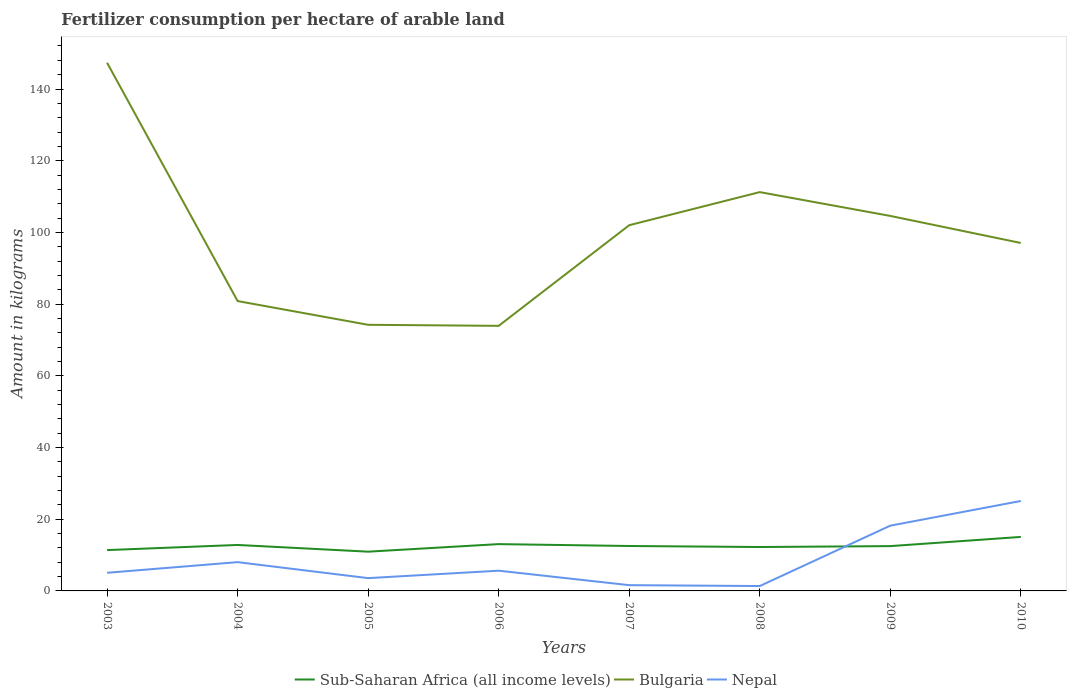How many different coloured lines are there?
Your answer should be compact. 3. Is the number of lines equal to the number of legend labels?
Provide a succinct answer. Yes. Across all years, what is the maximum amount of fertilizer consumption in Sub-Saharan Africa (all income levels)?
Your response must be concise. 10.95. What is the total amount of fertilizer consumption in Nepal in the graph?
Offer a very short reply. 4.03. What is the difference between the highest and the second highest amount of fertilizer consumption in Bulgaria?
Make the answer very short. 73.39. How many lines are there?
Make the answer very short. 3. How many years are there in the graph?
Offer a terse response. 8. Are the values on the major ticks of Y-axis written in scientific E-notation?
Offer a terse response. No. Does the graph contain any zero values?
Your answer should be compact. No. Does the graph contain grids?
Your answer should be compact. No. Where does the legend appear in the graph?
Ensure brevity in your answer.  Bottom center. What is the title of the graph?
Provide a succinct answer. Fertilizer consumption per hectare of arable land. What is the label or title of the X-axis?
Your answer should be very brief. Years. What is the label or title of the Y-axis?
Keep it short and to the point. Amount in kilograms. What is the Amount in kilograms in Sub-Saharan Africa (all income levels) in 2003?
Provide a succinct answer. 11.39. What is the Amount in kilograms in Bulgaria in 2003?
Ensure brevity in your answer.  147.33. What is the Amount in kilograms of Nepal in 2003?
Give a very brief answer. 5.06. What is the Amount in kilograms in Sub-Saharan Africa (all income levels) in 2004?
Your answer should be compact. 12.82. What is the Amount in kilograms of Bulgaria in 2004?
Ensure brevity in your answer.  80.85. What is the Amount in kilograms of Nepal in 2004?
Provide a short and direct response. 8.03. What is the Amount in kilograms of Sub-Saharan Africa (all income levels) in 2005?
Your response must be concise. 10.95. What is the Amount in kilograms of Bulgaria in 2005?
Give a very brief answer. 74.23. What is the Amount in kilograms in Nepal in 2005?
Your answer should be compact. 3.57. What is the Amount in kilograms of Sub-Saharan Africa (all income levels) in 2006?
Give a very brief answer. 13.06. What is the Amount in kilograms of Bulgaria in 2006?
Ensure brevity in your answer.  73.94. What is the Amount in kilograms in Nepal in 2006?
Offer a very short reply. 5.64. What is the Amount in kilograms of Sub-Saharan Africa (all income levels) in 2007?
Ensure brevity in your answer.  12.53. What is the Amount in kilograms of Bulgaria in 2007?
Make the answer very short. 102.01. What is the Amount in kilograms of Nepal in 2007?
Keep it short and to the point. 1.61. What is the Amount in kilograms of Sub-Saharan Africa (all income levels) in 2008?
Give a very brief answer. 12.25. What is the Amount in kilograms of Bulgaria in 2008?
Offer a terse response. 111.24. What is the Amount in kilograms in Nepal in 2008?
Provide a succinct answer. 1.36. What is the Amount in kilograms in Sub-Saharan Africa (all income levels) in 2009?
Keep it short and to the point. 12.5. What is the Amount in kilograms of Bulgaria in 2009?
Your answer should be very brief. 104.6. What is the Amount in kilograms of Nepal in 2009?
Make the answer very short. 18.2. What is the Amount in kilograms in Sub-Saharan Africa (all income levels) in 2010?
Your answer should be very brief. 15.06. What is the Amount in kilograms in Bulgaria in 2010?
Your answer should be very brief. 97.05. What is the Amount in kilograms in Nepal in 2010?
Your answer should be very brief. 25.09. Across all years, what is the maximum Amount in kilograms in Sub-Saharan Africa (all income levels)?
Your answer should be compact. 15.06. Across all years, what is the maximum Amount in kilograms of Bulgaria?
Your answer should be very brief. 147.33. Across all years, what is the maximum Amount in kilograms in Nepal?
Offer a terse response. 25.09. Across all years, what is the minimum Amount in kilograms in Sub-Saharan Africa (all income levels)?
Provide a succinct answer. 10.95. Across all years, what is the minimum Amount in kilograms in Bulgaria?
Give a very brief answer. 73.94. Across all years, what is the minimum Amount in kilograms in Nepal?
Make the answer very short. 1.36. What is the total Amount in kilograms in Sub-Saharan Africa (all income levels) in the graph?
Offer a terse response. 100.55. What is the total Amount in kilograms in Bulgaria in the graph?
Provide a short and direct response. 791.26. What is the total Amount in kilograms in Nepal in the graph?
Give a very brief answer. 68.56. What is the difference between the Amount in kilograms in Sub-Saharan Africa (all income levels) in 2003 and that in 2004?
Offer a terse response. -1.43. What is the difference between the Amount in kilograms in Bulgaria in 2003 and that in 2004?
Your response must be concise. 66.48. What is the difference between the Amount in kilograms of Nepal in 2003 and that in 2004?
Provide a short and direct response. -2.97. What is the difference between the Amount in kilograms of Sub-Saharan Africa (all income levels) in 2003 and that in 2005?
Your response must be concise. 0.44. What is the difference between the Amount in kilograms of Bulgaria in 2003 and that in 2005?
Give a very brief answer. 73.1. What is the difference between the Amount in kilograms in Nepal in 2003 and that in 2005?
Offer a very short reply. 1.49. What is the difference between the Amount in kilograms in Sub-Saharan Africa (all income levels) in 2003 and that in 2006?
Offer a terse response. -1.67. What is the difference between the Amount in kilograms of Bulgaria in 2003 and that in 2006?
Provide a succinct answer. 73.39. What is the difference between the Amount in kilograms in Nepal in 2003 and that in 2006?
Keep it short and to the point. -0.58. What is the difference between the Amount in kilograms of Sub-Saharan Africa (all income levels) in 2003 and that in 2007?
Keep it short and to the point. -1.14. What is the difference between the Amount in kilograms in Bulgaria in 2003 and that in 2007?
Provide a succinct answer. 45.32. What is the difference between the Amount in kilograms of Nepal in 2003 and that in 2007?
Make the answer very short. 3.45. What is the difference between the Amount in kilograms of Sub-Saharan Africa (all income levels) in 2003 and that in 2008?
Your answer should be very brief. -0.86. What is the difference between the Amount in kilograms in Bulgaria in 2003 and that in 2008?
Provide a short and direct response. 36.08. What is the difference between the Amount in kilograms in Nepal in 2003 and that in 2008?
Give a very brief answer. 3.69. What is the difference between the Amount in kilograms in Sub-Saharan Africa (all income levels) in 2003 and that in 2009?
Give a very brief answer. -1.11. What is the difference between the Amount in kilograms of Bulgaria in 2003 and that in 2009?
Make the answer very short. 42.73. What is the difference between the Amount in kilograms in Nepal in 2003 and that in 2009?
Offer a very short reply. -13.14. What is the difference between the Amount in kilograms of Sub-Saharan Africa (all income levels) in 2003 and that in 2010?
Offer a very short reply. -3.67. What is the difference between the Amount in kilograms in Bulgaria in 2003 and that in 2010?
Keep it short and to the point. 50.27. What is the difference between the Amount in kilograms of Nepal in 2003 and that in 2010?
Keep it short and to the point. -20.03. What is the difference between the Amount in kilograms of Sub-Saharan Africa (all income levels) in 2004 and that in 2005?
Provide a succinct answer. 1.87. What is the difference between the Amount in kilograms of Bulgaria in 2004 and that in 2005?
Your answer should be compact. 6.62. What is the difference between the Amount in kilograms of Nepal in 2004 and that in 2005?
Make the answer very short. 4.46. What is the difference between the Amount in kilograms in Sub-Saharan Africa (all income levels) in 2004 and that in 2006?
Offer a terse response. -0.24. What is the difference between the Amount in kilograms of Bulgaria in 2004 and that in 2006?
Provide a succinct answer. 6.91. What is the difference between the Amount in kilograms of Nepal in 2004 and that in 2006?
Offer a very short reply. 2.38. What is the difference between the Amount in kilograms of Sub-Saharan Africa (all income levels) in 2004 and that in 2007?
Give a very brief answer. 0.29. What is the difference between the Amount in kilograms of Bulgaria in 2004 and that in 2007?
Provide a succinct answer. -21.16. What is the difference between the Amount in kilograms in Nepal in 2004 and that in 2007?
Give a very brief answer. 6.42. What is the difference between the Amount in kilograms in Sub-Saharan Africa (all income levels) in 2004 and that in 2008?
Offer a very short reply. 0.57. What is the difference between the Amount in kilograms of Bulgaria in 2004 and that in 2008?
Offer a very short reply. -30.39. What is the difference between the Amount in kilograms of Nepal in 2004 and that in 2008?
Keep it short and to the point. 6.66. What is the difference between the Amount in kilograms of Sub-Saharan Africa (all income levels) in 2004 and that in 2009?
Your response must be concise. 0.32. What is the difference between the Amount in kilograms of Bulgaria in 2004 and that in 2009?
Your response must be concise. -23.75. What is the difference between the Amount in kilograms in Nepal in 2004 and that in 2009?
Make the answer very short. -10.18. What is the difference between the Amount in kilograms of Sub-Saharan Africa (all income levels) in 2004 and that in 2010?
Ensure brevity in your answer.  -2.24. What is the difference between the Amount in kilograms of Bulgaria in 2004 and that in 2010?
Ensure brevity in your answer.  -16.2. What is the difference between the Amount in kilograms of Nepal in 2004 and that in 2010?
Your answer should be very brief. -17.06. What is the difference between the Amount in kilograms in Sub-Saharan Africa (all income levels) in 2005 and that in 2006?
Offer a very short reply. -2.11. What is the difference between the Amount in kilograms in Bulgaria in 2005 and that in 2006?
Ensure brevity in your answer.  0.29. What is the difference between the Amount in kilograms of Nepal in 2005 and that in 2006?
Offer a very short reply. -2.07. What is the difference between the Amount in kilograms of Sub-Saharan Africa (all income levels) in 2005 and that in 2007?
Give a very brief answer. -1.58. What is the difference between the Amount in kilograms in Bulgaria in 2005 and that in 2007?
Your response must be concise. -27.78. What is the difference between the Amount in kilograms in Nepal in 2005 and that in 2007?
Offer a very short reply. 1.96. What is the difference between the Amount in kilograms of Sub-Saharan Africa (all income levels) in 2005 and that in 2008?
Your answer should be compact. -1.3. What is the difference between the Amount in kilograms of Bulgaria in 2005 and that in 2008?
Offer a terse response. -37.01. What is the difference between the Amount in kilograms in Nepal in 2005 and that in 2008?
Provide a succinct answer. 2.2. What is the difference between the Amount in kilograms of Sub-Saharan Africa (all income levels) in 2005 and that in 2009?
Provide a short and direct response. -1.55. What is the difference between the Amount in kilograms of Bulgaria in 2005 and that in 2009?
Your response must be concise. -30.37. What is the difference between the Amount in kilograms in Nepal in 2005 and that in 2009?
Your answer should be very brief. -14.63. What is the difference between the Amount in kilograms in Sub-Saharan Africa (all income levels) in 2005 and that in 2010?
Make the answer very short. -4.11. What is the difference between the Amount in kilograms in Bulgaria in 2005 and that in 2010?
Keep it short and to the point. -22.82. What is the difference between the Amount in kilograms in Nepal in 2005 and that in 2010?
Ensure brevity in your answer.  -21.52. What is the difference between the Amount in kilograms of Sub-Saharan Africa (all income levels) in 2006 and that in 2007?
Make the answer very short. 0.53. What is the difference between the Amount in kilograms of Bulgaria in 2006 and that in 2007?
Your answer should be compact. -28.07. What is the difference between the Amount in kilograms in Nepal in 2006 and that in 2007?
Provide a succinct answer. 4.03. What is the difference between the Amount in kilograms of Sub-Saharan Africa (all income levels) in 2006 and that in 2008?
Your response must be concise. 0.81. What is the difference between the Amount in kilograms in Bulgaria in 2006 and that in 2008?
Offer a terse response. -37.3. What is the difference between the Amount in kilograms of Nepal in 2006 and that in 2008?
Give a very brief answer. 4.28. What is the difference between the Amount in kilograms of Sub-Saharan Africa (all income levels) in 2006 and that in 2009?
Ensure brevity in your answer.  0.56. What is the difference between the Amount in kilograms in Bulgaria in 2006 and that in 2009?
Ensure brevity in your answer.  -30.66. What is the difference between the Amount in kilograms of Nepal in 2006 and that in 2009?
Give a very brief answer. -12.56. What is the difference between the Amount in kilograms in Sub-Saharan Africa (all income levels) in 2006 and that in 2010?
Give a very brief answer. -2. What is the difference between the Amount in kilograms in Bulgaria in 2006 and that in 2010?
Give a very brief answer. -23.11. What is the difference between the Amount in kilograms of Nepal in 2006 and that in 2010?
Give a very brief answer. -19.44. What is the difference between the Amount in kilograms in Sub-Saharan Africa (all income levels) in 2007 and that in 2008?
Offer a terse response. 0.28. What is the difference between the Amount in kilograms in Bulgaria in 2007 and that in 2008?
Provide a succinct answer. -9.23. What is the difference between the Amount in kilograms in Nepal in 2007 and that in 2008?
Give a very brief answer. 0.24. What is the difference between the Amount in kilograms of Sub-Saharan Africa (all income levels) in 2007 and that in 2009?
Ensure brevity in your answer.  0.03. What is the difference between the Amount in kilograms in Bulgaria in 2007 and that in 2009?
Your answer should be compact. -2.59. What is the difference between the Amount in kilograms in Nepal in 2007 and that in 2009?
Ensure brevity in your answer.  -16.59. What is the difference between the Amount in kilograms in Sub-Saharan Africa (all income levels) in 2007 and that in 2010?
Make the answer very short. -2.53. What is the difference between the Amount in kilograms in Bulgaria in 2007 and that in 2010?
Your answer should be compact. 4.96. What is the difference between the Amount in kilograms of Nepal in 2007 and that in 2010?
Provide a short and direct response. -23.48. What is the difference between the Amount in kilograms in Sub-Saharan Africa (all income levels) in 2008 and that in 2009?
Your response must be concise. -0.25. What is the difference between the Amount in kilograms in Bulgaria in 2008 and that in 2009?
Your answer should be very brief. 6.64. What is the difference between the Amount in kilograms in Nepal in 2008 and that in 2009?
Your answer should be very brief. -16.84. What is the difference between the Amount in kilograms in Sub-Saharan Africa (all income levels) in 2008 and that in 2010?
Give a very brief answer. -2.81. What is the difference between the Amount in kilograms of Bulgaria in 2008 and that in 2010?
Your answer should be very brief. 14.19. What is the difference between the Amount in kilograms in Nepal in 2008 and that in 2010?
Offer a very short reply. -23.72. What is the difference between the Amount in kilograms in Sub-Saharan Africa (all income levels) in 2009 and that in 2010?
Offer a terse response. -2.56. What is the difference between the Amount in kilograms of Bulgaria in 2009 and that in 2010?
Offer a terse response. 7.55. What is the difference between the Amount in kilograms in Nepal in 2009 and that in 2010?
Your answer should be very brief. -6.88. What is the difference between the Amount in kilograms in Sub-Saharan Africa (all income levels) in 2003 and the Amount in kilograms in Bulgaria in 2004?
Provide a succinct answer. -69.46. What is the difference between the Amount in kilograms of Sub-Saharan Africa (all income levels) in 2003 and the Amount in kilograms of Nepal in 2004?
Make the answer very short. 3.37. What is the difference between the Amount in kilograms of Bulgaria in 2003 and the Amount in kilograms of Nepal in 2004?
Your answer should be very brief. 139.3. What is the difference between the Amount in kilograms in Sub-Saharan Africa (all income levels) in 2003 and the Amount in kilograms in Bulgaria in 2005?
Make the answer very short. -62.84. What is the difference between the Amount in kilograms of Sub-Saharan Africa (all income levels) in 2003 and the Amount in kilograms of Nepal in 2005?
Offer a very short reply. 7.82. What is the difference between the Amount in kilograms of Bulgaria in 2003 and the Amount in kilograms of Nepal in 2005?
Give a very brief answer. 143.76. What is the difference between the Amount in kilograms of Sub-Saharan Africa (all income levels) in 2003 and the Amount in kilograms of Bulgaria in 2006?
Make the answer very short. -62.55. What is the difference between the Amount in kilograms in Sub-Saharan Africa (all income levels) in 2003 and the Amount in kilograms in Nepal in 2006?
Your answer should be very brief. 5.75. What is the difference between the Amount in kilograms in Bulgaria in 2003 and the Amount in kilograms in Nepal in 2006?
Provide a succinct answer. 141.69. What is the difference between the Amount in kilograms of Sub-Saharan Africa (all income levels) in 2003 and the Amount in kilograms of Bulgaria in 2007?
Provide a succinct answer. -90.62. What is the difference between the Amount in kilograms of Sub-Saharan Africa (all income levels) in 2003 and the Amount in kilograms of Nepal in 2007?
Offer a very short reply. 9.78. What is the difference between the Amount in kilograms of Bulgaria in 2003 and the Amount in kilograms of Nepal in 2007?
Keep it short and to the point. 145.72. What is the difference between the Amount in kilograms of Sub-Saharan Africa (all income levels) in 2003 and the Amount in kilograms of Bulgaria in 2008?
Offer a terse response. -99.85. What is the difference between the Amount in kilograms of Sub-Saharan Africa (all income levels) in 2003 and the Amount in kilograms of Nepal in 2008?
Your response must be concise. 10.03. What is the difference between the Amount in kilograms of Bulgaria in 2003 and the Amount in kilograms of Nepal in 2008?
Keep it short and to the point. 145.96. What is the difference between the Amount in kilograms in Sub-Saharan Africa (all income levels) in 2003 and the Amount in kilograms in Bulgaria in 2009?
Make the answer very short. -93.21. What is the difference between the Amount in kilograms of Sub-Saharan Africa (all income levels) in 2003 and the Amount in kilograms of Nepal in 2009?
Provide a succinct answer. -6.81. What is the difference between the Amount in kilograms in Bulgaria in 2003 and the Amount in kilograms in Nepal in 2009?
Offer a terse response. 129.12. What is the difference between the Amount in kilograms of Sub-Saharan Africa (all income levels) in 2003 and the Amount in kilograms of Bulgaria in 2010?
Provide a short and direct response. -85.66. What is the difference between the Amount in kilograms in Sub-Saharan Africa (all income levels) in 2003 and the Amount in kilograms in Nepal in 2010?
Keep it short and to the point. -13.7. What is the difference between the Amount in kilograms of Bulgaria in 2003 and the Amount in kilograms of Nepal in 2010?
Give a very brief answer. 122.24. What is the difference between the Amount in kilograms of Sub-Saharan Africa (all income levels) in 2004 and the Amount in kilograms of Bulgaria in 2005?
Offer a terse response. -61.41. What is the difference between the Amount in kilograms of Sub-Saharan Africa (all income levels) in 2004 and the Amount in kilograms of Nepal in 2005?
Provide a short and direct response. 9.25. What is the difference between the Amount in kilograms of Bulgaria in 2004 and the Amount in kilograms of Nepal in 2005?
Provide a succinct answer. 77.28. What is the difference between the Amount in kilograms in Sub-Saharan Africa (all income levels) in 2004 and the Amount in kilograms in Bulgaria in 2006?
Offer a terse response. -61.12. What is the difference between the Amount in kilograms of Sub-Saharan Africa (all income levels) in 2004 and the Amount in kilograms of Nepal in 2006?
Keep it short and to the point. 7.18. What is the difference between the Amount in kilograms in Bulgaria in 2004 and the Amount in kilograms in Nepal in 2006?
Offer a very short reply. 75.21. What is the difference between the Amount in kilograms in Sub-Saharan Africa (all income levels) in 2004 and the Amount in kilograms in Bulgaria in 2007?
Provide a succinct answer. -89.19. What is the difference between the Amount in kilograms of Sub-Saharan Africa (all income levels) in 2004 and the Amount in kilograms of Nepal in 2007?
Provide a succinct answer. 11.21. What is the difference between the Amount in kilograms in Bulgaria in 2004 and the Amount in kilograms in Nepal in 2007?
Keep it short and to the point. 79.24. What is the difference between the Amount in kilograms of Sub-Saharan Africa (all income levels) in 2004 and the Amount in kilograms of Bulgaria in 2008?
Keep it short and to the point. -98.42. What is the difference between the Amount in kilograms in Sub-Saharan Africa (all income levels) in 2004 and the Amount in kilograms in Nepal in 2008?
Offer a terse response. 11.46. What is the difference between the Amount in kilograms in Bulgaria in 2004 and the Amount in kilograms in Nepal in 2008?
Keep it short and to the point. 79.49. What is the difference between the Amount in kilograms in Sub-Saharan Africa (all income levels) in 2004 and the Amount in kilograms in Bulgaria in 2009?
Your answer should be compact. -91.78. What is the difference between the Amount in kilograms in Sub-Saharan Africa (all income levels) in 2004 and the Amount in kilograms in Nepal in 2009?
Keep it short and to the point. -5.38. What is the difference between the Amount in kilograms of Bulgaria in 2004 and the Amount in kilograms of Nepal in 2009?
Make the answer very short. 62.65. What is the difference between the Amount in kilograms of Sub-Saharan Africa (all income levels) in 2004 and the Amount in kilograms of Bulgaria in 2010?
Provide a short and direct response. -84.23. What is the difference between the Amount in kilograms in Sub-Saharan Africa (all income levels) in 2004 and the Amount in kilograms in Nepal in 2010?
Your response must be concise. -12.27. What is the difference between the Amount in kilograms of Bulgaria in 2004 and the Amount in kilograms of Nepal in 2010?
Ensure brevity in your answer.  55.77. What is the difference between the Amount in kilograms in Sub-Saharan Africa (all income levels) in 2005 and the Amount in kilograms in Bulgaria in 2006?
Your answer should be compact. -62.99. What is the difference between the Amount in kilograms in Sub-Saharan Africa (all income levels) in 2005 and the Amount in kilograms in Nepal in 2006?
Offer a very short reply. 5.31. What is the difference between the Amount in kilograms of Bulgaria in 2005 and the Amount in kilograms of Nepal in 2006?
Provide a succinct answer. 68.59. What is the difference between the Amount in kilograms of Sub-Saharan Africa (all income levels) in 2005 and the Amount in kilograms of Bulgaria in 2007?
Keep it short and to the point. -91.06. What is the difference between the Amount in kilograms in Sub-Saharan Africa (all income levels) in 2005 and the Amount in kilograms in Nepal in 2007?
Offer a very short reply. 9.34. What is the difference between the Amount in kilograms of Bulgaria in 2005 and the Amount in kilograms of Nepal in 2007?
Ensure brevity in your answer.  72.62. What is the difference between the Amount in kilograms of Sub-Saharan Africa (all income levels) in 2005 and the Amount in kilograms of Bulgaria in 2008?
Give a very brief answer. -100.29. What is the difference between the Amount in kilograms of Sub-Saharan Africa (all income levels) in 2005 and the Amount in kilograms of Nepal in 2008?
Give a very brief answer. 9.58. What is the difference between the Amount in kilograms in Bulgaria in 2005 and the Amount in kilograms in Nepal in 2008?
Provide a short and direct response. 72.87. What is the difference between the Amount in kilograms of Sub-Saharan Africa (all income levels) in 2005 and the Amount in kilograms of Bulgaria in 2009?
Make the answer very short. -93.65. What is the difference between the Amount in kilograms in Sub-Saharan Africa (all income levels) in 2005 and the Amount in kilograms in Nepal in 2009?
Make the answer very short. -7.25. What is the difference between the Amount in kilograms of Bulgaria in 2005 and the Amount in kilograms of Nepal in 2009?
Provide a short and direct response. 56.03. What is the difference between the Amount in kilograms of Sub-Saharan Africa (all income levels) in 2005 and the Amount in kilograms of Bulgaria in 2010?
Give a very brief answer. -86.1. What is the difference between the Amount in kilograms in Sub-Saharan Africa (all income levels) in 2005 and the Amount in kilograms in Nepal in 2010?
Keep it short and to the point. -14.14. What is the difference between the Amount in kilograms in Bulgaria in 2005 and the Amount in kilograms in Nepal in 2010?
Give a very brief answer. 49.15. What is the difference between the Amount in kilograms of Sub-Saharan Africa (all income levels) in 2006 and the Amount in kilograms of Bulgaria in 2007?
Offer a terse response. -88.95. What is the difference between the Amount in kilograms of Sub-Saharan Africa (all income levels) in 2006 and the Amount in kilograms of Nepal in 2007?
Your answer should be compact. 11.45. What is the difference between the Amount in kilograms of Bulgaria in 2006 and the Amount in kilograms of Nepal in 2007?
Offer a very short reply. 72.33. What is the difference between the Amount in kilograms of Sub-Saharan Africa (all income levels) in 2006 and the Amount in kilograms of Bulgaria in 2008?
Offer a very short reply. -98.19. What is the difference between the Amount in kilograms of Sub-Saharan Africa (all income levels) in 2006 and the Amount in kilograms of Nepal in 2008?
Make the answer very short. 11.69. What is the difference between the Amount in kilograms in Bulgaria in 2006 and the Amount in kilograms in Nepal in 2008?
Ensure brevity in your answer.  72.58. What is the difference between the Amount in kilograms of Sub-Saharan Africa (all income levels) in 2006 and the Amount in kilograms of Bulgaria in 2009?
Your response must be concise. -91.54. What is the difference between the Amount in kilograms in Sub-Saharan Africa (all income levels) in 2006 and the Amount in kilograms in Nepal in 2009?
Make the answer very short. -5.15. What is the difference between the Amount in kilograms in Bulgaria in 2006 and the Amount in kilograms in Nepal in 2009?
Your answer should be very brief. 55.74. What is the difference between the Amount in kilograms of Sub-Saharan Africa (all income levels) in 2006 and the Amount in kilograms of Bulgaria in 2010?
Give a very brief answer. -84. What is the difference between the Amount in kilograms in Sub-Saharan Africa (all income levels) in 2006 and the Amount in kilograms in Nepal in 2010?
Give a very brief answer. -12.03. What is the difference between the Amount in kilograms of Bulgaria in 2006 and the Amount in kilograms of Nepal in 2010?
Your answer should be compact. 48.85. What is the difference between the Amount in kilograms in Sub-Saharan Africa (all income levels) in 2007 and the Amount in kilograms in Bulgaria in 2008?
Ensure brevity in your answer.  -98.71. What is the difference between the Amount in kilograms of Sub-Saharan Africa (all income levels) in 2007 and the Amount in kilograms of Nepal in 2008?
Provide a short and direct response. 11.16. What is the difference between the Amount in kilograms of Bulgaria in 2007 and the Amount in kilograms of Nepal in 2008?
Ensure brevity in your answer.  100.64. What is the difference between the Amount in kilograms in Sub-Saharan Africa (all income levels) in 2007 and the Amount in kilograms in Bulgaria in 2009?
Your response must be concise. -92.07. What is the difference between the Amount in kilograms in Sub-Saharan Africa (all income levels) in 2007 and the Amount in kilograms in Nepal in 2009?
Keep it short and to the point. -5.67. What is the difference between the Amount in kilograms of Bulgaria in 2007 and the Amount in kilograms of Nepal in 2009?
Ensure brevity in your answer.  83.81. What is the difference between the Amount in kilograms in Sub-Saharan Africa (all income levels) in 2007 and the Amount in kilograms in Bulgaria in 2010?
Keep it short and to the point. -84.53. What is the difference between the Amount in kilograms in Sub-Saharan Africa (all income levels) in 2007 and the Amount in kilograms in Nepal in 2010?
Keep it short and to the point. -12.56. What is the difference between the Amount in kilograms of Bulgaria in 2007 and the Amount in kilograms of Nepal in 2010?
Your answer should be compact. 76.92. What is the difference between the Amount in kilograms in Sub-Saharan Africa (all income levels) in 2008 and the Amount in kilograms in Bulgaria in 2009?
Provide a short and direct response. -92.35. What is the difference between the Amount in kilograms in Sub-Saharan Africa (all income levels) in 2008 and the Amount in kilograms in Nepal in 2009?
Provide a succinct answer. -5.96. What is the difference between the Amount in kilograms of Bulgaria in 2008 and the Amount in kilograms of Nepal in 2009?
Provide a succinct answer. 93.04. What is the difference between the Amount in kilograms of Sub-Saharan Africa (all income levels) in 2008 and the Amount in kilograms of Bulgaria in 2010?
Your answer should be very brief. -84.81. What is the difference between the Amount in kilograms of Sub-Saharan Africa (all income levels) in 2008 and the Amount in kilograms of Nepal in 2010?
Ensure brevity in your answer.  -12.84. What is the difference between the Amount in kilograms in Bulgaria in 2008 and the Amount in kilograms in Nepal in 2010?
Provide a short and direct response. 86.16. What is the difference between the Amount in kilograms in Sub-Saharan Africa (all income levels) in 2009 and the Amount in kilograms in Bulgaria in 2010?
Provide a short and direct response. -84.55. What is the difference between the Amount in kilograms in Sub-Saharan Africa (all income levels) in 2009 and the Amount in kilograms in Nepal in 2010?
Your response must be concise. -12.59. What is the difference between the Amount in kilograms of Bulgaria in 2009 and the Amount in kilograms of Nepal in 2010?
Your answer should be very brief. 79.51. What is the average Amount in kilograms of Sub-Saharan Africa (all income levels) per year?
Your response must be concise. 12.57. What is the average Amount in kilograms of Bulgaria per year?
Keep it short and to the point. 98.91. What is the average Amount in kilograms in Nepal per year?
Your answer should be compact. 8.57. In the year 2003, what is the difference between the Amount in kilograms of Sub-Saharan Africa (all income levels) and Amount in kilograms of Bulgaria?
Your answer should be very brief. -135.94. In the year 2003, what is the difference between the Amount in kilograms in Sub-Saharan Africa (all income levels) and Amount in kilograms in Nepal?
Give a very brief answer. 6.33. In the year 2003, what is the difference between the Amount in kilograms of Bulgaria and Amount in kilograms of Nepal?
Offer a terse response. 142.27. In the year 2004, what is the difference between the Amount in kilograms in Sub-Saharan Africa (all income levels) and Amount in kilograms in Bulgaria?
Provide a succinct answer. -68.03. In the year 2004, what is the difference between the Amount in kilograms of Sub-Saharan Africa (all income levels) and Amount in kilograms of Nepal?
Your response must be concise. 4.8. In the year 2004, what is the difference between the Amount in kilograms in Bulgaria and Amount in kilograms in Nepal?
Provide a succinct answer. 72.83. In the year 2005, what is the difference between the Amount in kilograms in Sub-Saharan Africa (all income levels) and Amount in kilograms in Bulgaria?
Your answer should be compact. -63.28. In the year 2005, what is the difference between the Amount in kilograms of Sub-Saharan Africa (all income levels) and Amount in kilograms of Nepal?
Provide a short and direct response. 7.38. In the year 2005, what is the difference between the Amount in kilograms of Bulgaria and Amount in kilograms of Nepal?
Give a very brief answer. 70.66. In the year 2006, what is the difference between the Amount in kilograms in Sub-Saharan Africa (all income levels) and Amount in kilograms in Bulgaria?
Offer a terse response. -60.88. In the year 2006, what is the difference between the Amount in kilograms in Sub-Saharan Africa (all income levels) and Amount in kilograms in Nepal?
Provide a short and direct response. 7.42. In the year 2006, what is the difference between the Amount in kilograms of Bulgaria and Amount in kilograms of Nepal?
Ensure brevity in your answer.  68.3. In the year 2007, what is the difference between the Amount in kilograms of Sub-Saharan Africa (all income levels) and Amount in kilograms of Bulgaria?
Keep it short and to the point. -89.48. In the year 2007, what is the difference between the Amount in kilograms of Sub-Saharan Africa (all income levels) and Amount in kilograms of Nepal?
Provide a succinct answer. 10.92. In the year 2007, what is the difference between the Amount in kilograms in Bulgaria and Amount in kilograms in Nepal?
Your answer should be very brief. 100.4. In the year 2008, what is the difference between the Amount in kilograms in Sub-Saharan Africa (all income levels) and Amount in kilograms in Bulgaria?
Keep it short and to the point. -99. In the year 2008, what is the difference between the Amount in kilograms of Sub-Saharan Africa (all income levels) and Amount in kilograms of Nepal?
Provide a succinct answer. 10.88. In the year 2008, what is the difference between the Amount in kilograms of Bulgaria and Amount in kilograms of Nepal?
Your response must be concise. 109.88. In the year 2009, what is the difference between the Amount in kilograms of Sub-Saharan Africa (all income levels) and Amount in kilograms of Bulgaria?
Keep it short and to the point. -92.1. In the year 2009, what is the difference between the Amount in kilograms of Sub-Saharan Africa (all income levels) and Amount in kilograms of Nepal?
Keep it short and to the point. -5.7. In the year 2009, what is the difference between the Amount in kilograms of Bulgaria and Amount in kilograms of Nepal?
Your response must be concise. 86.4. In the year 2010, what is the difference between the Amount in kilograms in Sub-Saharan Africa (all income levels) and Amount in kilograms in Bulgaria?
Offer a terse response. -81.99. In the year 2010, what is the difference between the Amount in kilograms of Sub-Saharan Africa (all income levels) and Amount in kilograms of Nepal?
Offer a very short reply. -10.03. In the year 2010, what is the difference between the Amount in kilograms of Bulgaria and Amount in kilograms of Nepal?
Make the answer very short. 71.97. What is the ratio of the Amount in kilograms of Sub-Saharan Africa (all income levels) in 2003 to that in 2004?
Your response must be concise. 0.89. What is the ratio of the Amount in kilograms in Bulgaria in 2003 to that in 2004?
Offer a terse response. 1.82. What is the ratio of the Amount in kilograms of Nepal in 2003 to that in 2004?
Give a very brief answer. 0.63. What is the ratio of the Amount in kilograms of Sub-Saharan Africa (all income levels) in 2003 to that in 2005?
Ensure brevity in your answer.  1.04. What is the ratio of the Amount in kilograms of Bulgaria in 2003 to that in 2005?
Your answer should be compact. 1.98. What is the ratio of the Amount in kilograms of Nepal in 2003 to that in 2005?
Provide a succinct answer. 1.42. What is the ratio of the Amount in kilograms in Sub-Saharan Africa (all income levels) in 2003 to that in 2006?
Make the answer very short. 0.87. What is the ratio of the Amount in kilograms in Bulgaria in 2003 to that in 2006?
Make the answer very short. 1.99. What is the ratio of the Amount in kilograms in Nepal in 2003 to that in 2006?
Your response must be concise. 0.9. What is the ratio of the Amount in kilograms of Sub-Saharan Africa (all income levels) in 2003 to that in 2007?
Provide a succinct answer. 0.91. What is the ratio of the Amount in kilograms of Bulgaria in 2003 to that in 2007?
Ensure brevity in your answer.  1.44. What is the ratio of the Amount in kilograms in Nepal in 2003 to that in 2007?
Your answer should be very brief. 3.14. What is the ratio of the Amount in kilograms in Bulgaria in 2003 to that in 2008?
Provide a succinct answer. 1.32. What is the ratio of the Amount in kilograms in Nepal in 2003 to that in 2008?
Your answer should be very brief. 3.71. What is the ratio of the Amount in kilograms in Sub-Saharan Africa (all income levels) in 2003 to that in 2009?
Your answer should be compact. 0.91. What is the ratio of the Amount in kilograms of Bulgaria in 2003 to that in 2009?
Your response must be concise. 1.41. What is the ratio of the Amount in kilograms in Nepal in 2003 to that in 2009?
Your answer should be very brief. 0.28. What is the ratio of the Amount in kilograms of Sub-Saharan Africa (all income levels) in 2003 to that in 2010?
Make the answer very short. 0.76. What is the ratio of the Amount in kilograms of Bulgaria in 2003 to that in 2010?
Your response must be concise. 1.52. What is the ratio of the Amount in kilograms in Nepal in 2003 to that in 2010?
Your answer should be very brief. 0.2. What is the ratio of the Amount in kilograms in Sub-Saharan Africa (all income levels) in 2004 to that in 2005?
Ensure brevity in your answer.  1.17. What is the ratio of the Amount in kilograms of Bulgaria in 2004 to that in 2005?
Ensure brevity in your answer.  1.09. What is the ratio of the Amount in kilograms of Nepal in 2004 to that in 2005?
Give a very brief answer. 2.25. What is the ratio of the Amount in kilograms in Sub-Saharan Africa (all income levels) in 2004 to that in 2006?
Offer a terse response. 0.98. What is the ratio of the Amount in kilograms of Bulgaria in 2004 to that in 2006?
Provide a succinct answer. 1.09. What is the ratio of the Amount in kilograms of Nepal in 2004 to that in 2006?
Provide a succinct answer. 1.42. What is the ratio of the Amount in kilograms in Sub-Saharan Africa (all income levels) in 2004 to that in 2007?
Your answer should be very brief. 1.02. What is the ratio of the Amount in kilograms in Bulgaria in 2004 to that in 2007?
Your response must be concise. 0.79. What is the ratio of the Amount in kilograms in Nepal in 2004 to that in 2007?
Keep it short and to the point. 4.99. What is the ratio of the Amount in kilograms in Sub-Saharan Africa (all income levels) in 2004 to that in 2008?
Offer a very short reply. 1.05. What is the ratio of the Amount in kilograms of Bulgaria in 2004 to that in 2008?
Your answer should be compact. 0.73. What is the ratio of the Amount in kilograms in Nepal in 2004 to that in 2008?
Give a very brief answer. 5.88. What is the ratio of the Amount in kilograms of Sub-Saharan Africa (all income levels) in 2004 to that in 2009?
Your answer should be compact. 1.03. What is the ratio of the Amount in kilograms of Bulgaria in 2004 to that in 2009?
Offer a very short reply. 0.77. What is the ratio of the Amount in kilograms in Nepal in 2004 to that in 2009?
Keep it short and to the point. 0.44. What is the ratio of the Amount in kilograms of Sub-Saharan Africa (all income levels) in 2004 to that in 2010?
Your response must be concise. 0.85. What is the ratio of the Amount in kilograms of Bulgaria in 2004 to that in 2010?
Keep it short and to the point. 0.83. What is the ratio of the Amount in kilograms in Nepal in 2004 to that in 2010?
Provide a succinct answer. 0.32. What is the ratio of the Amount in kilograms in Sub-Saharan Africa (all income levels) in 2005 to that in 2006?
Your answer should be compact. 0.84. What is the ratio of the Amount in kilograms in Bulgaria in 2005 to that in 2006?
Your answer should be compact. 1. What is the ratio of the Amount in kilograms of Nepal in 2005 to that in 2006?
Keep it short and to the point. 0.63. What is the ratio of the Amount in kilograms of Sub-Saharan Africa (all income levels) in 2005 to that in 2007?
Your answer should be compact. 0.87. What is the ratio of the Amount in kilograms of Bulgaria in 2005 to that in 2007?
Offer a terse response. 0.73. What is the ratio of the Amount in kilograms in Nepal in 2005 to that in 2007?
Your answer should be very brief. 2.22. What is the ratio of the Amount in kilograms in Sub-Saharan Africa (all income levels) in 2005 to that in 2008?
Your response must be concise. 0.89. What is the ratio of the Amount in kilograms in Bulgaria in 2005 to that in 2008?
Offer a very short reply. 0.67. What is the ratio of the Amount in kilograms in Nepal in 2005 to that in 2008?
Give a very brief answer. 2.61. What is the ratio of the Amount in kilograms of Sub-Saharan Africa (all income levels) in 2005 to that in 2009?
Keep it short and to the point. 0.88. What is the ratio of the Amount in kilograms in Bulgaria in 2005 to that in 2009?
Make the answer very short. 0.71. What is the ratio of the Amount in kilograms of Nepal in 2005 to that in 2009?
Your response must be concise. 0.2. What is the ratio of the Amount in kilograms in Sub-Saharan Africa (all income levels) in 2005 to that in 2010?
Provide a succinct answer. 0.73. What is the ratio of the Amount in kilograms in Bulgaria in 2005 to that in 2010?
Make the answer very short. 0.76. What is the ratio of the Amount in kilograms in Nepal in 2005 to that in 2010?
Ensure brevity in your answer.  0.14. What is the ratio of the Amount in kilograms of Sub-Saharan Africa (all income levels) in 2006 to that in 2007?
Provide a succinct answer. 1.04. What is the ratio of the Amount in kilograms in Bulgaria in 2006 to that in 2007?
Your answer should be very brief. 0.72. What is the ratio of the Amount in kilograms of Nepal in 2006 to that in 2007?
Your answer should be very brief. 3.51. What is the ratio of the Amount in kilograms in Sub-Saharan Africa (all income levels) in 2006 to that in 2008?
Provide a succinct answer. 1.07. What is the ratio of the Amount in kilograms of Bulgaria in 2006 to that in 2008?
Your response must be concise. 0.66. What is the ratio of the Amount in kilograms of Nepal in 2006 to that in 2008?
Provide a succinct answer. 4.13. What is the ratio of the Amount in kilograms of Sub-Saharan Africa (all income levels) in 2006 to that in 2009?
Provide a short and direct response. 1.04. What is the ratio of the Amount in kilograms of Bulgaria in 2006 to that in 2009?
Give a very brief answer. 0.71. What is the ratio of the Amount in kilograms in Nepal in 2006 to that in 2009?
Your answer should be very brief. 0.31. What is the ratio of the Amount in kilograms of Sub-Saharan Africa (all income levels) in 2006 to that in 2010?
Ensure brevity in your answer.  0.87. What is the ratio of the Amount in kilograms of Bulgaria in 2006 to that in 2010?
Provide a short and direct response. 0.76. What is the ratio of the Amount in kilograms of Nepal in 2006 to that in 2010?
Keep it short and to the point. 0.22. What is the ratio of the Amount in kilograms in Sub-Saharan Africa (all income levels) in 2007 to that in 2008?
Your answer should be very brief. 1.02. What is the ratio of the Amount in kilograms of Bulgaria in 2007 to that in 2008?
Your response must be concise. 0.92. What is the ratio of the Amount in kilograms in Nepal in 2007 to that in 2008?
Give a very brief answer. 1.18. What is the ratio of the Amount in kilograms of Sub-Saharan Africa (all income levels) in 2007 to that in 2009?
Your answer should be compact. 1. What is the ratio of the Amount in kilograms in Bulgaria in 2007 to that in 2009?
Give a very brief answer. 0.98. What is the ratio of the Amount in kilograms in Nepal in 2007 to that in 2009?
Make the answer very short. 0.09. What is the ratio of the Amount in kilograms of Sub-Saharan Africa (all income levels) in 2007 to that in 2010?
Provide a short and direct response. 0.83. What is the ratio of the Amount in kilograms in Bulgaria in 2007 to that in 2010?
Keep it short and to the point. 1.05. What is the ratio of the Amount in kilograms of Nepal in 2007 to that in 2010?
Ensure brevity in your answer.  0.06. What is the ratio of the Amount in kilograms in Sub-Saharan Africa (all income levels) in 2008 to that in 2009?
Make the answer very short. 0.98. What is the ratio of the Amount in kilograms of Bulgaria in 2008 to that in 2009?
Your response must be concise. 1.06. What is the ratio of the Amount in kilograms in Nepal in 2008 to that in 2009?
Your answer should be very brief. 0.07. What is the ratio of the Amount in kilograms of Sub-Saharan Africa (all income levels) in 2008 to that in 2010?
Your answer should be very brief. 0.81. What is the ratio of the Amount in kilograms in Bulgaria in 2008 to that in 2010?
Your response must be concise. 1.15. What is the ratio of the Amount in kilograms of Nepal in 2008 to that in 2010?
Provide a succinct answer. 0.05. What is the ratio of the Amount in kilograms in Sub-Saharan Africa (all income levels) in 2009 to that in 2010?
Your response must be concise. 0.83. What is the ratio of the Amount in kilograms of Bulgaria in 2009 to that in 2010?
Your answer should be very brief. 1.08. What is the ratio of the Amount in kilograms of Nepal in 2009 to that in 2010?
Your answer should be compact. 0.73. What is the difference between the highest and the second highest Amount in kilograms in Sub-Saharan Africa (all income levels)?
Your answer should be compact. 2. What is the difference between the highest and the second highest Amount in kilograms of Bulgaria?
Provide a short and direct response. 36.08. What is the difference between the highest and the second highest Amount in kilograms of Nepal?
Offer a very short reply. 6.88. What is the difference between the highest and the lowest Amount in kilograms in Sub-Saharan Africa (all income levels)?
Offer a very short reply. 4.11. What is the difference between the highest and the lowest Amount in kilograms in Bulgaria?
Ensure brevity in your answer.  73.39. What is the difference between the highest and the lowest Amount in kilograms of Nepal?
Provide a succinct answer. 23.72. 